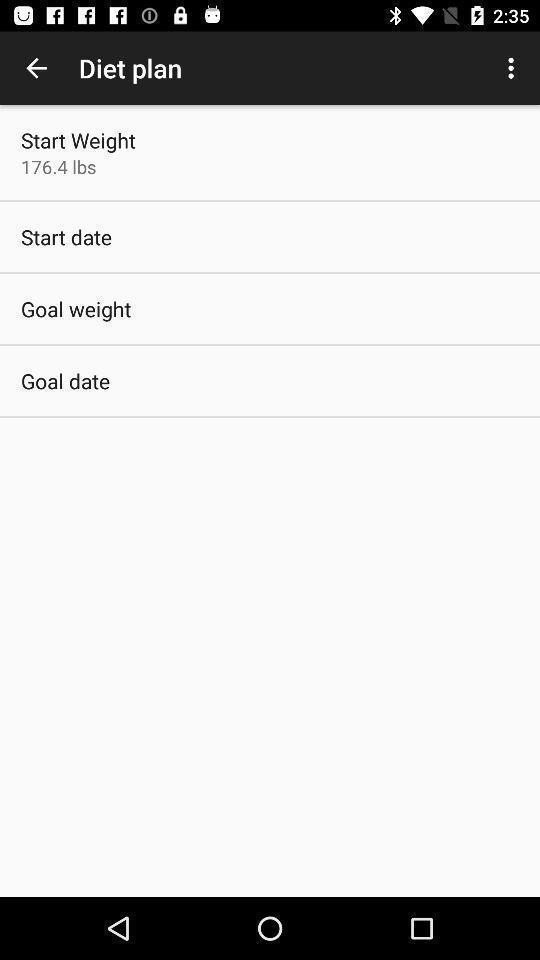Provide a description of this screenshot. Screen shows different diet plans. 